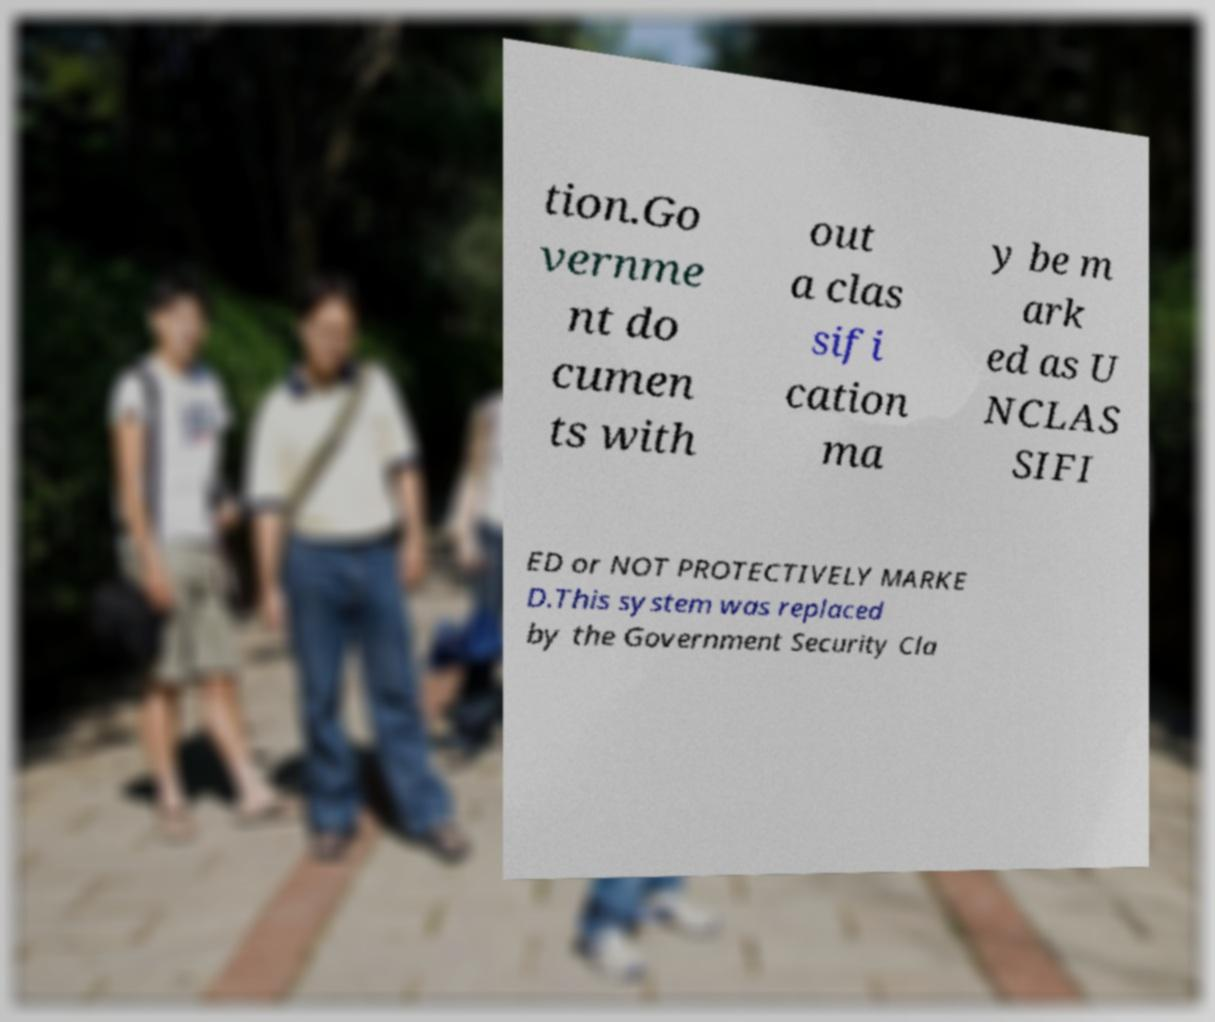There's text embedded in this image that I need extracted. Can you transcribe it verbatim? tion.Go vernme nt do cumen ts with out a clas sifi cation ma y be m ark ed as U NCLAS SIFI ED or NOT PROTECTIVELY MARKE D.This system was replaced by the Government Security Cla 